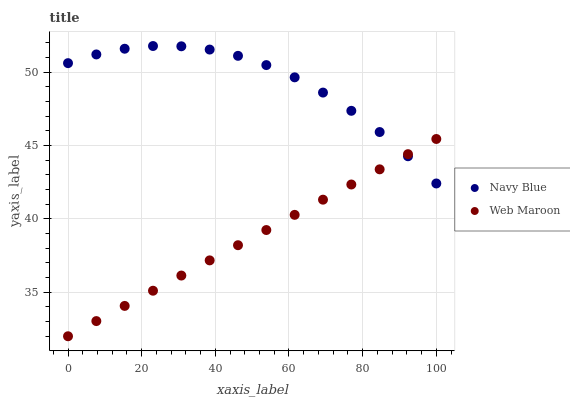Does Web Maroon have the minimum area under the curve?
Answer yes or no. Yes. Does Navy Blue have the maximum area under the curve?
Answer yes or no. Yes. Does Web Maroon have the maximum area under the curve?
Answer yes or no. No. Is Web Maroon the smoothest?
Answer yes or no. Yes. Is Navy Blue the roughest?
Answer yes or no. Yes. Is Web Maroon the roughest?
Answer yes or no. No. Does Web Maroon have the lowest value?
Answer yes or no. Yes. Does Navy Blue have the highest value?
Answer yes or no. Yes. Does Web Maroon have the highest value?
Answer yes or no. No. Does Navy Blue intersect Web Maroon?
Answer yes or no. Yes. Is Navy Blue less than Web Maroon?
Answer yes or no. No. Is Navy Blue greater than Web Maroon?
Answer yes or no. No. 